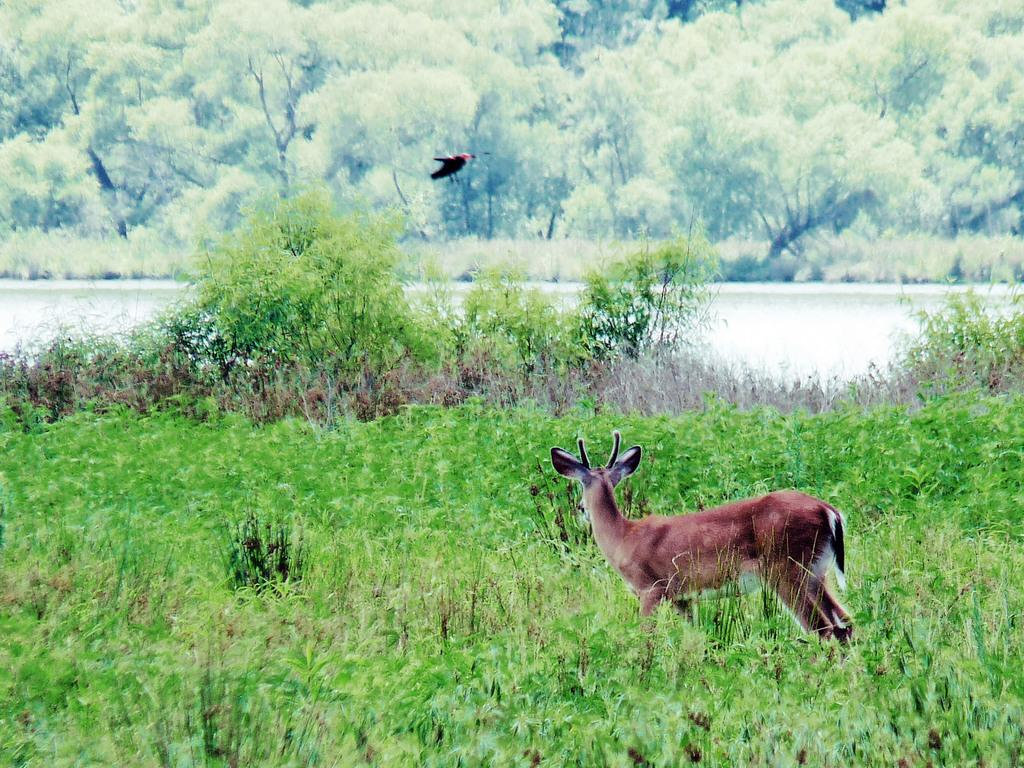What animal can be seen on the grass in the image? There is a fox on the surface of the grass. What is the bird doing in the image? The bird is flying in the air. What body of water is present in the image? There is a river in the middle of the image. What type of vegetation can be seen in the background of the image? There are trees in the background of the image. What type of paper is floating on the river in the image? There is no paper present in the image; it only features a fox, a bird, a river, and trees. 